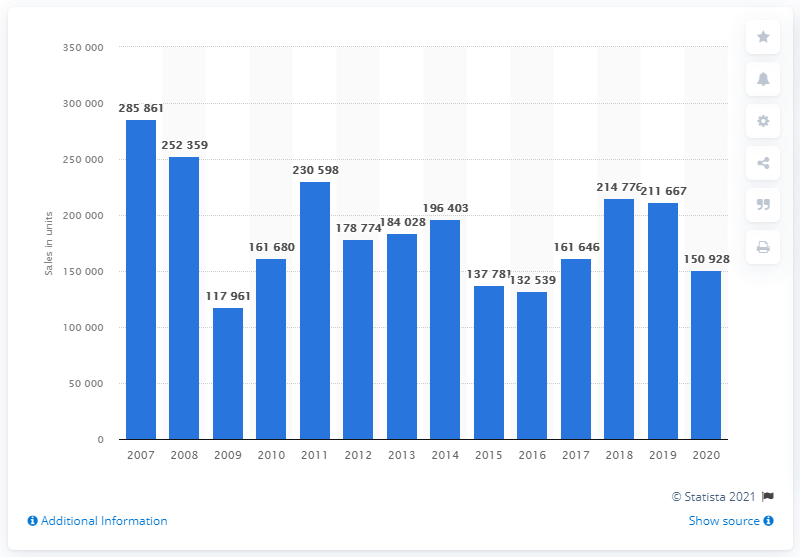Give some essential details in this illustration. In the year 2007, Deutz AG's unit sales were first reported. 